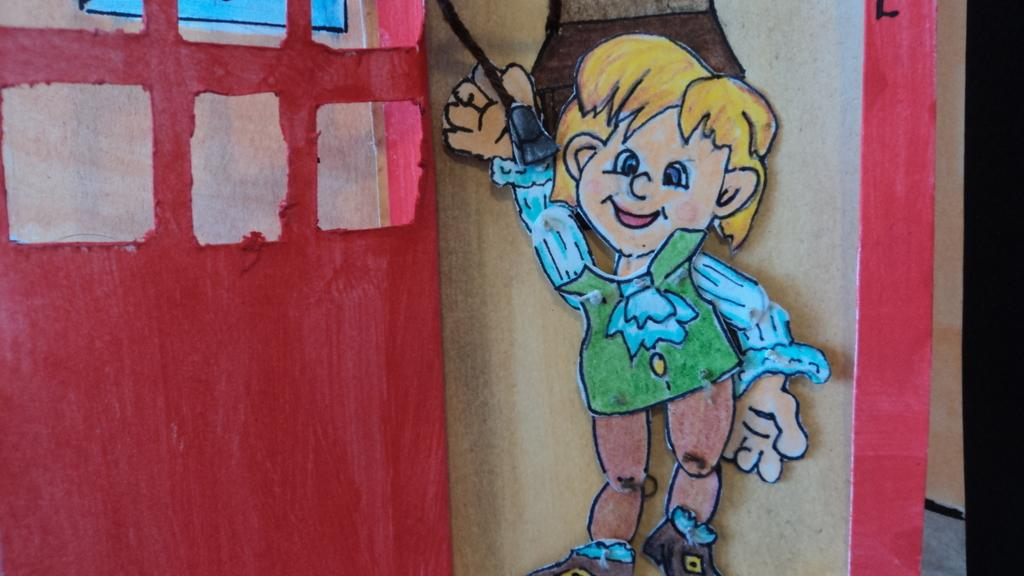What is present on the wall in the image? There is a painting on the wall in the image. What is the subject of the painting? The painting depicts a boy holding a curtain. Is the boy reading a book in the painting? No, the boy is not reading a book in the painting; he is holding a curtain. 